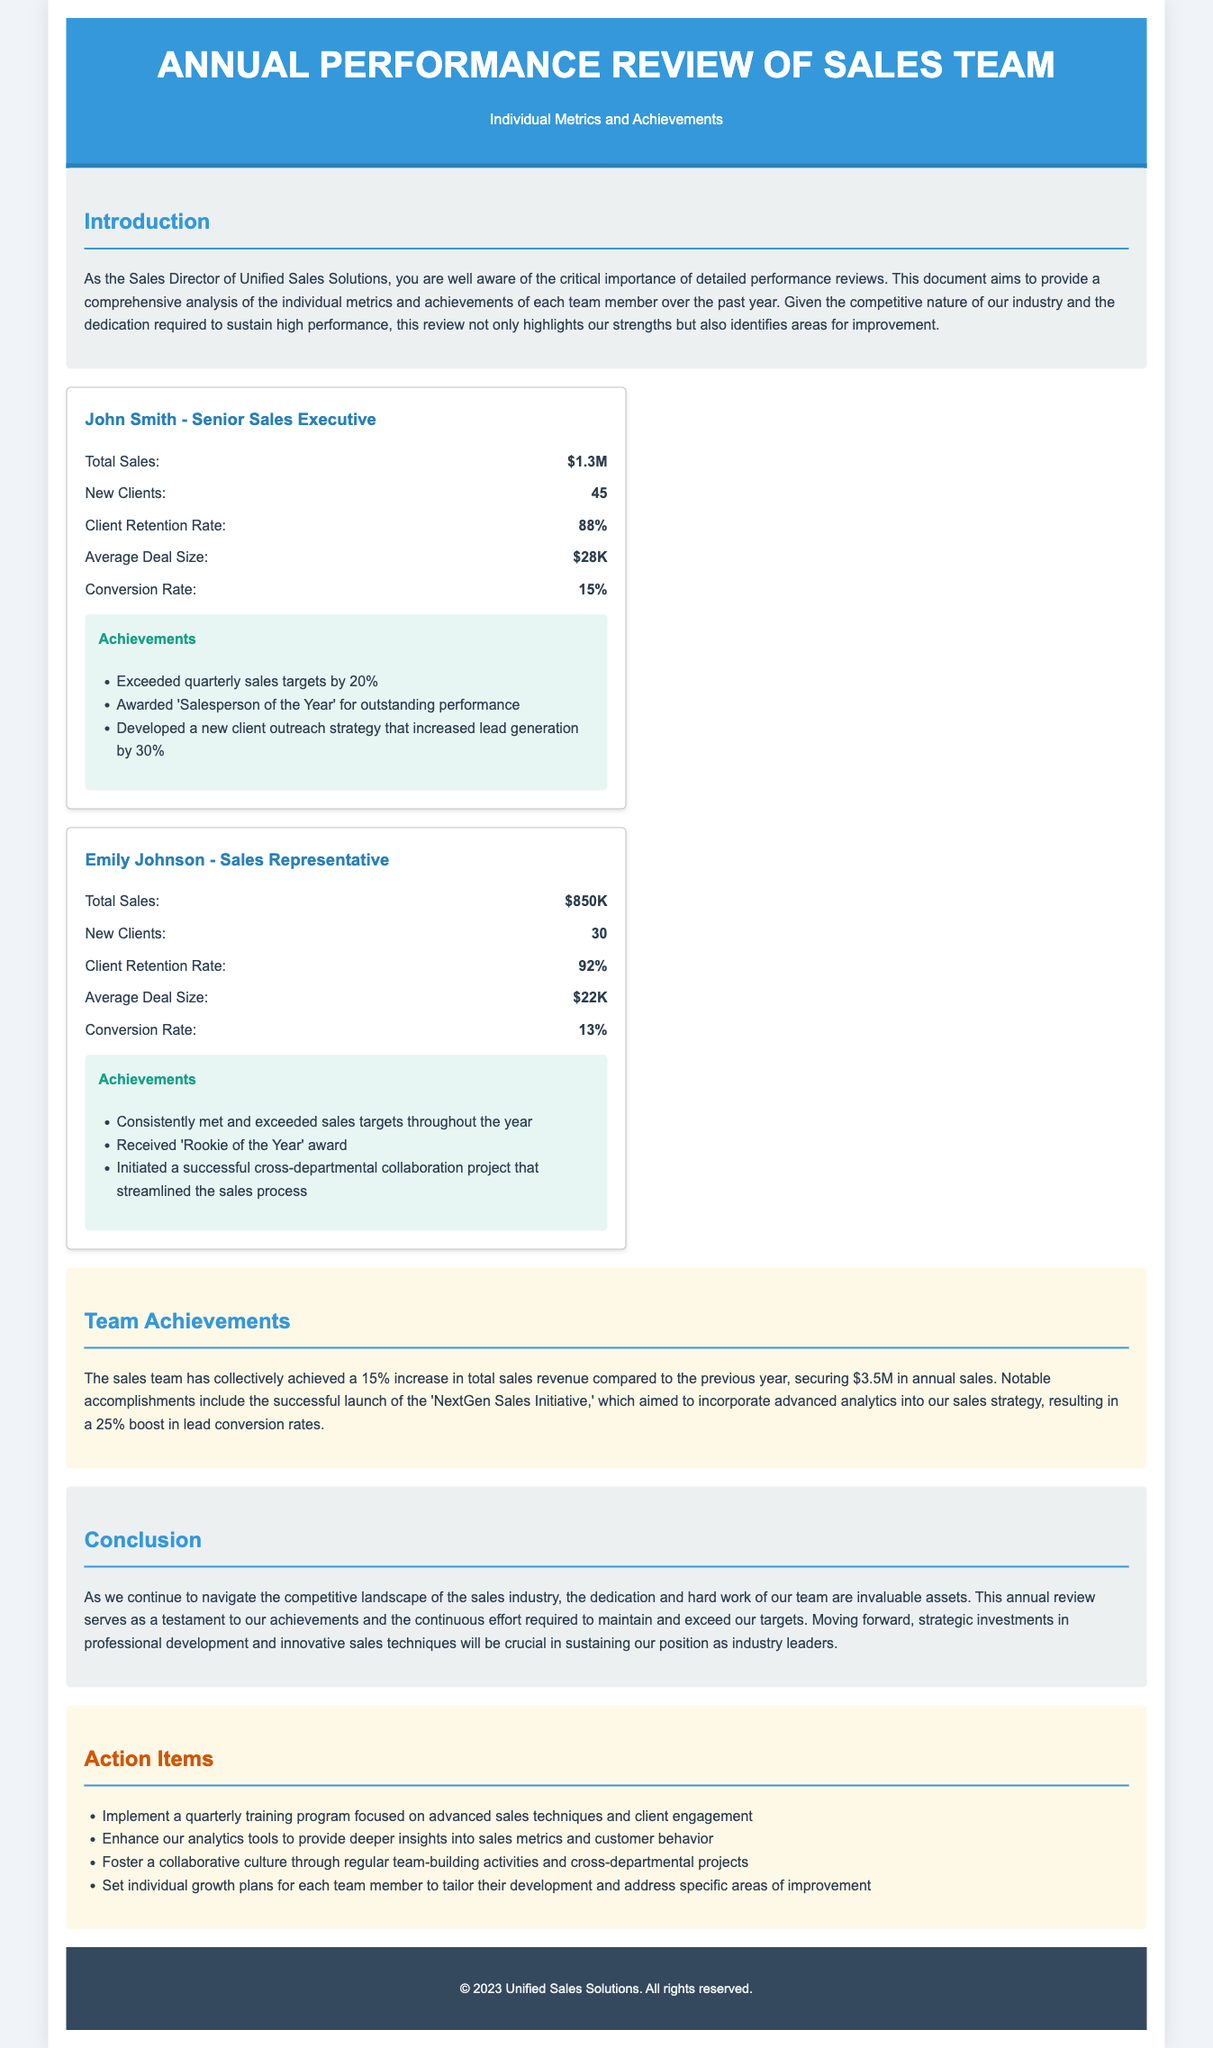What is the total sales for John Smith? The total sales for John Smith is stated clearly in the metrics section of the document.
Answer: $1.3M What award did John Smith receive? The document specifically mentions the award he received under his achievements.
Answer: Salesperson of the Year How many new clients did Emily Johnson acquire? The new clients for Emily Johnson are listed in her metric card in the document.
Answer: 30 What is the team’s total sales revenue for the year? The total sales revenue for the team is given in the team achievements section.
Answer: $3.5M What is the client retention rate for Emily Johnson? The retention rate is specifically outlined in the metrics section for each team member.
Answer: 92% What was the percentage increase in total sales revenue? The increase percentage for total sales revenue is provided in the team achievements section.
Answer: 15% What is one of the action items listed in the document? The action items section outlines specific steps to be taken moving forward.
Answer: Implement a quarterly training program What significant initiative did the sales team launch? The document refers to an initiative that had a significant impact on sales metrics.
Answer: NextGen Sales Initiative What is the average deal size for John Smith? The average deal size is mentioned in the metrics section under John Smith's details.
Answer: $28K 